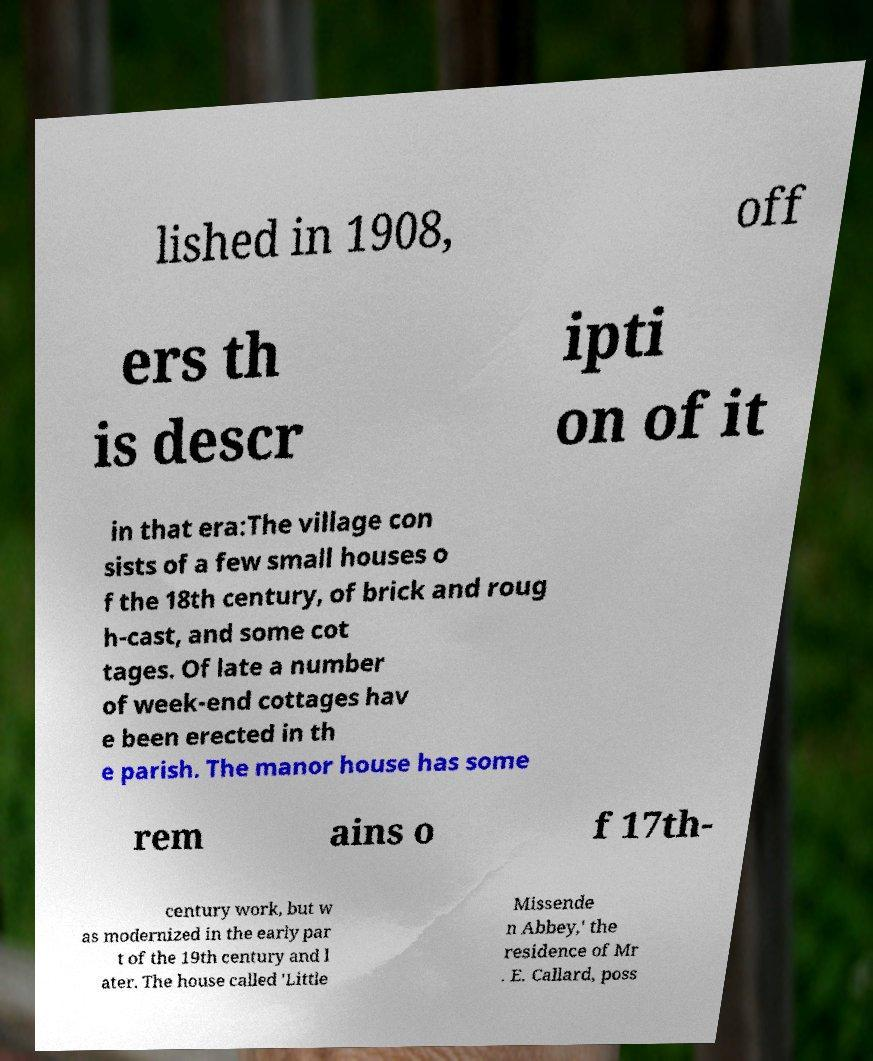What messages or text are displayed in this image? I need them in a readable, typed format. lished in 1908, off ers th is descr ipti on of it in that era:The village con sists of a few small houses o f the 18th century, of brick and roug h-cast, and some cot tages. Of late a number of week-end cottages hav e been erected in th e parish. The manor house has some rem ains o f 17th- century work, but w as modernized in the early par t of the 19th century and l ater. The house called 'Little Missende n Abbey,' the residence of Mr . E. Callard, poss 